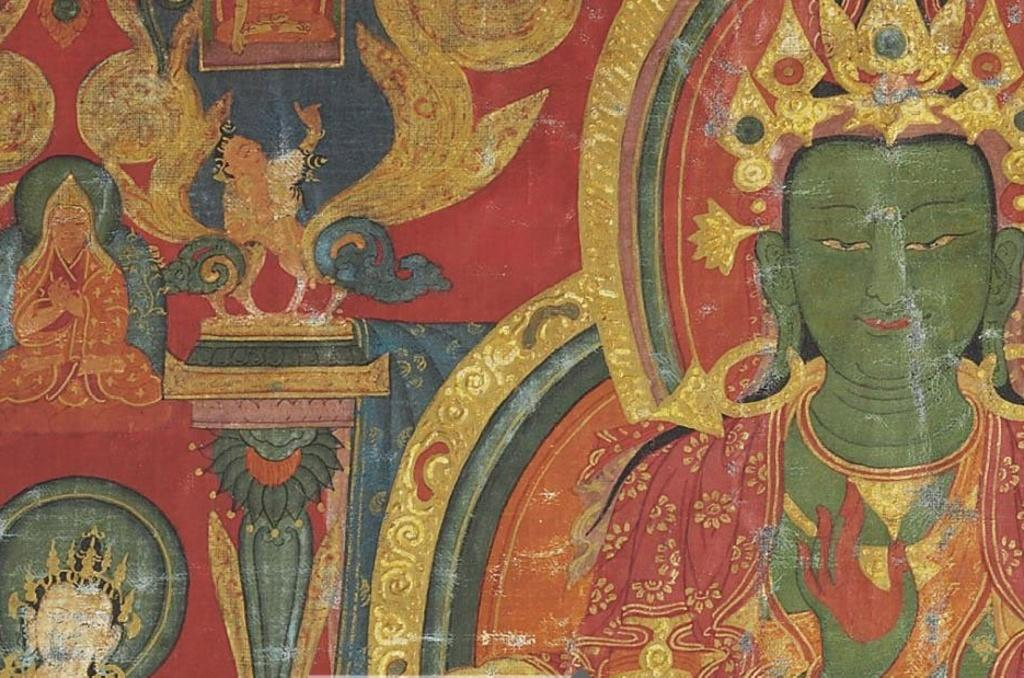What is the main subject of the image? There is a painting in the image. Can you describe the painting? The painting has different colors. What is the theme or subject matter of the painting? The painting is related to a god. What type of fuel is being used in the painting? There is no fuel present in the painting, as it is a painting of a god and not a depiction of a vehicle or machinery. 